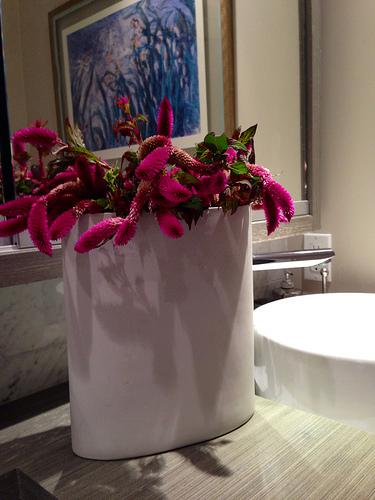Question: where is the vase?
Choices:
A. On the table.
B. Under the sink.
C. In the cabinet.
D. On the counter.
Answer with the letter. Answer: D Question: what color are the flowers?
Choices:
A. Red.
B. Yellow.
C. Pink.
D. White.
Answer with the letter. Answer: C Question: why did they take the picture?
Choices:
A. To show how pretty the flowers were.
B. The view was beautiful.
C. For memories.
D. The family was together.
Answer with the letter. Answer: A Question: what is in the vase?
Choices:
A. Sticks.
B. Rocks.
C. Shells.
D. Flowers.
Answer with the letter. Answer: D 